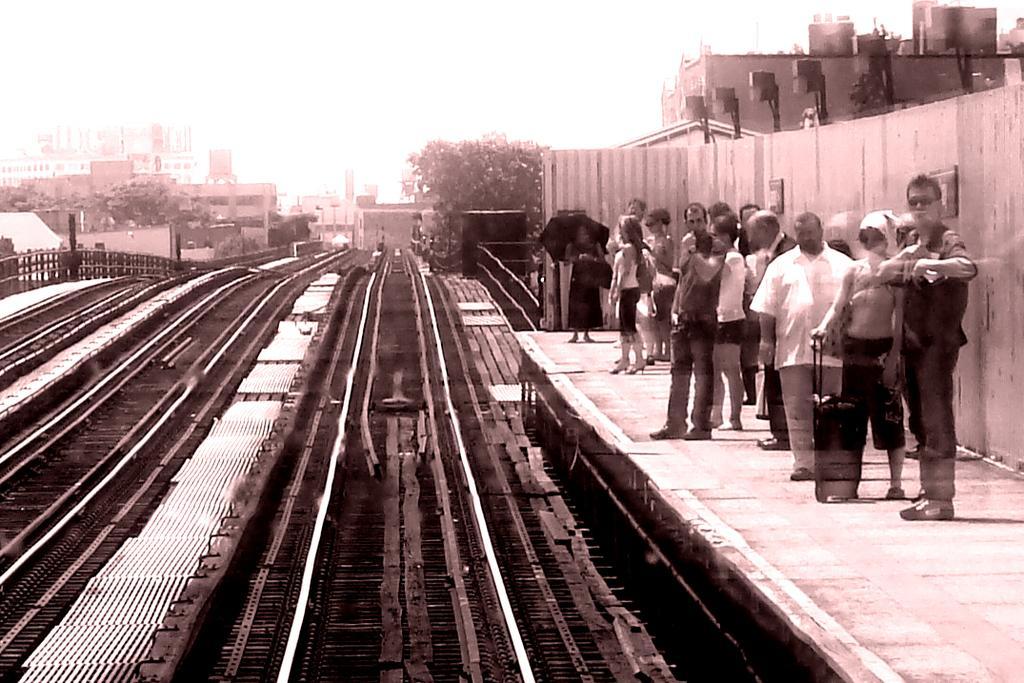Could you give a brief overview of what you see in this image? This picture is clicked outside. On the left we can see the railway tracks. On the right we can see the group of people standing on the railway platform. In the background there is a sky, trees and buildings. 